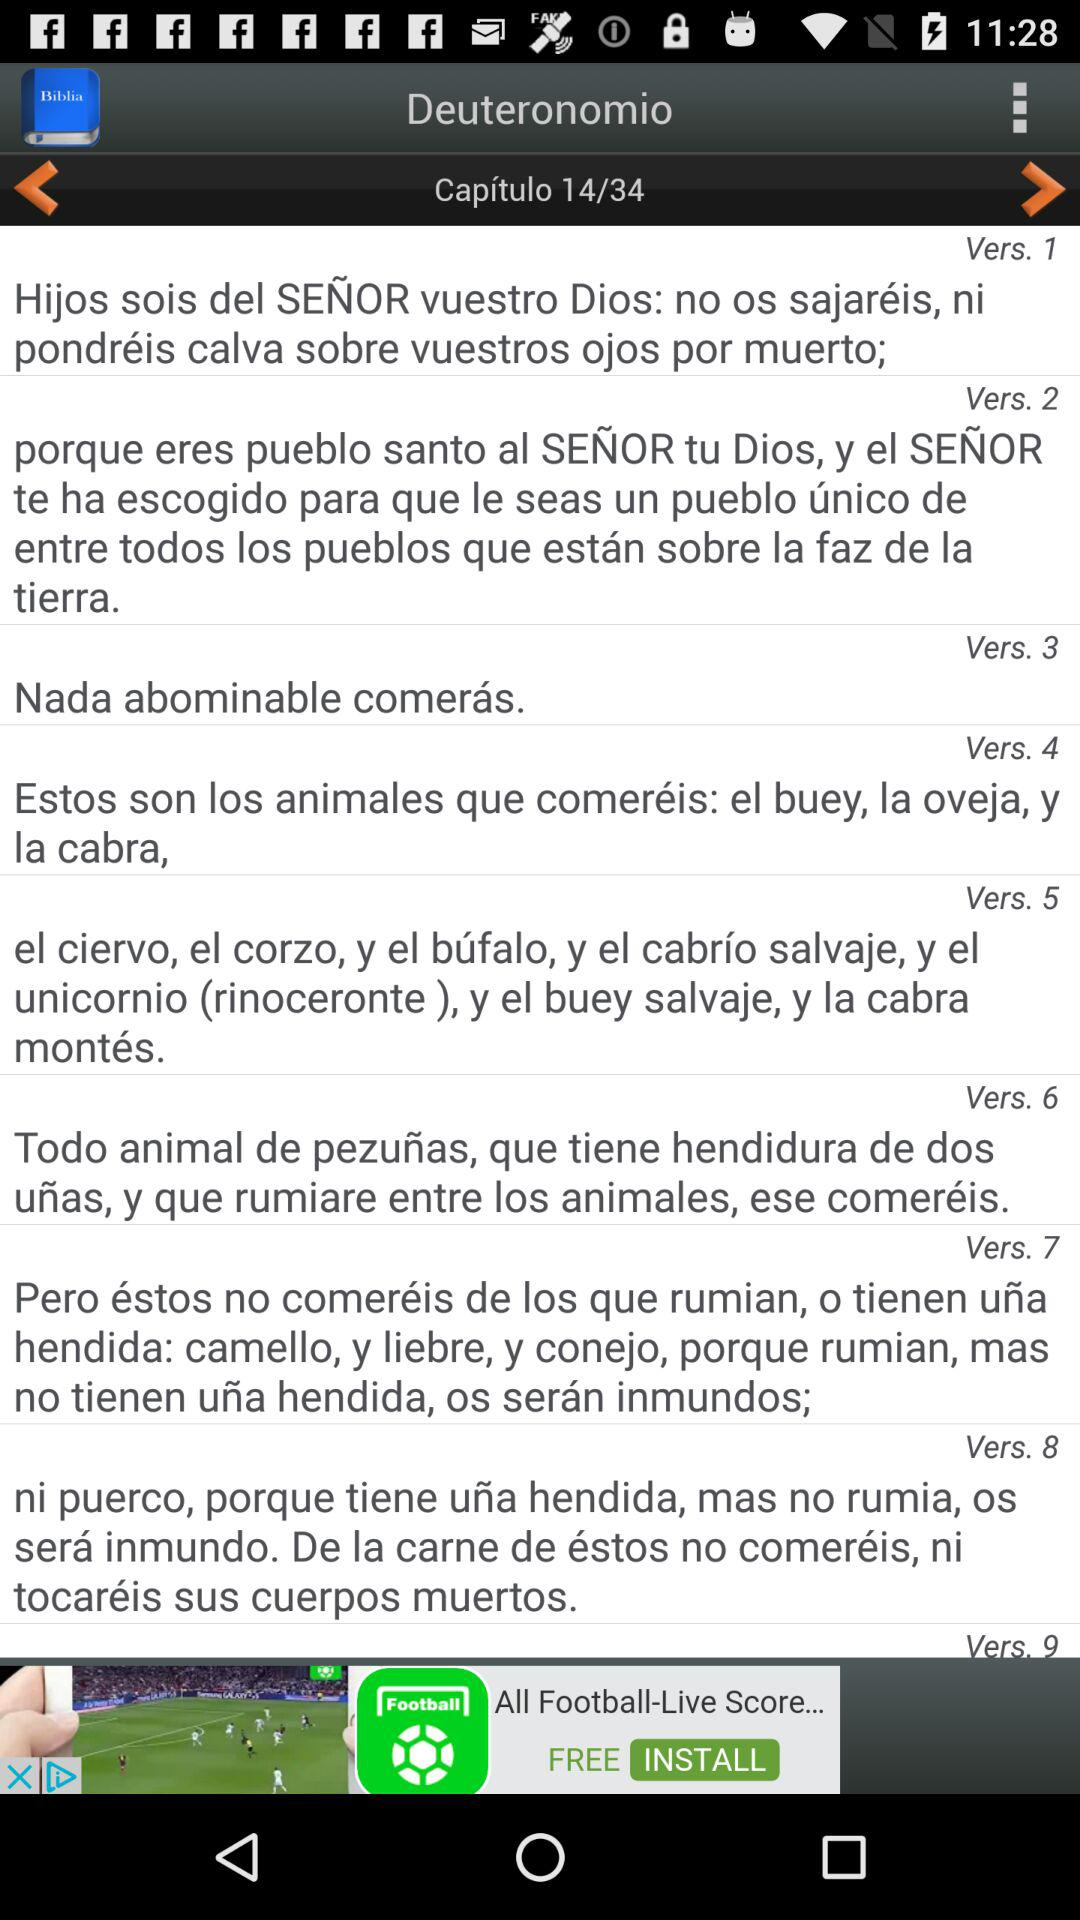How many verses are there in the chapter?
Answer the question using a single word or phrase. 9 